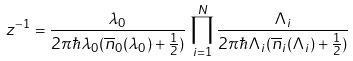Convert formula to latex. <formula><loc_0><loc_0><loc_500><loc_500>z ^ { - 1 } = \frac { \lambda _ { 0 } } { 2 \pi \hbar { \lambda } _ { 0 } ( \overline { n } _ { 0 } ( \lambda _ { 0 } ) + \frac { 1 } { 2 } ) } \, \prod _ { i = 1 } ^ { N } \frac { \Lambda _ { i } } { 2 \pi \hbar { \Lambda } _ { i } ( \overline { n } _ { i } ( \Lambda _ { i } ) + \frac { 1 } { 2 } ) }</formula> 